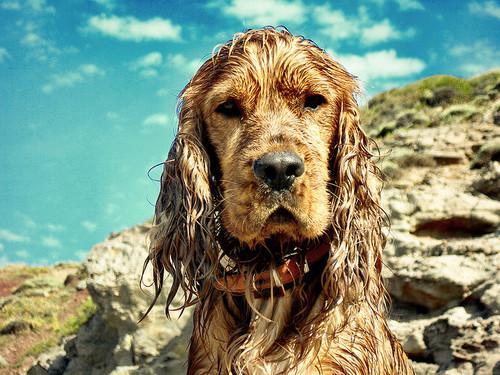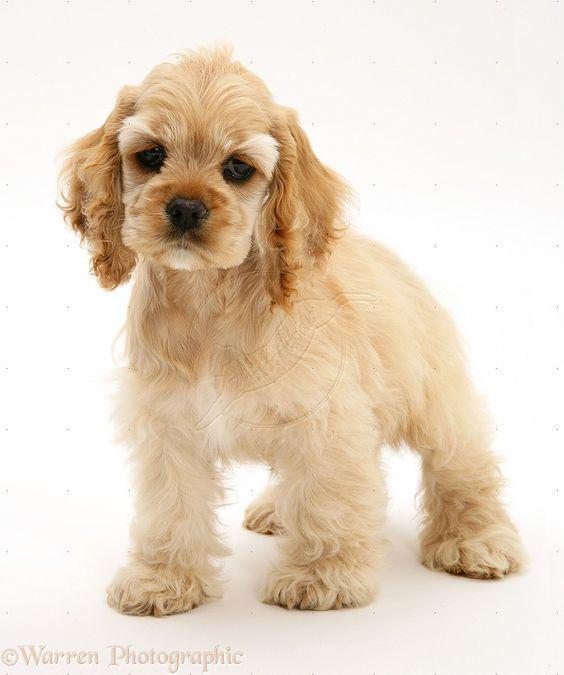The first image is the image on the left, the second image is the image on the right. Assess this claim about the two images: "One image shows an upright spaniel with bedraggled wet fur, especially on its ears, and the other image shows one spaniel with a coat of dry fur in one color.". Correct or not? Answer yes or no. Yes. The first image is the image on the left, the second image is the image on the right. Examine the images to the left and right. Is the description "The dogs in each of the images are situated outside." accurate? Answer yes or no. No. 